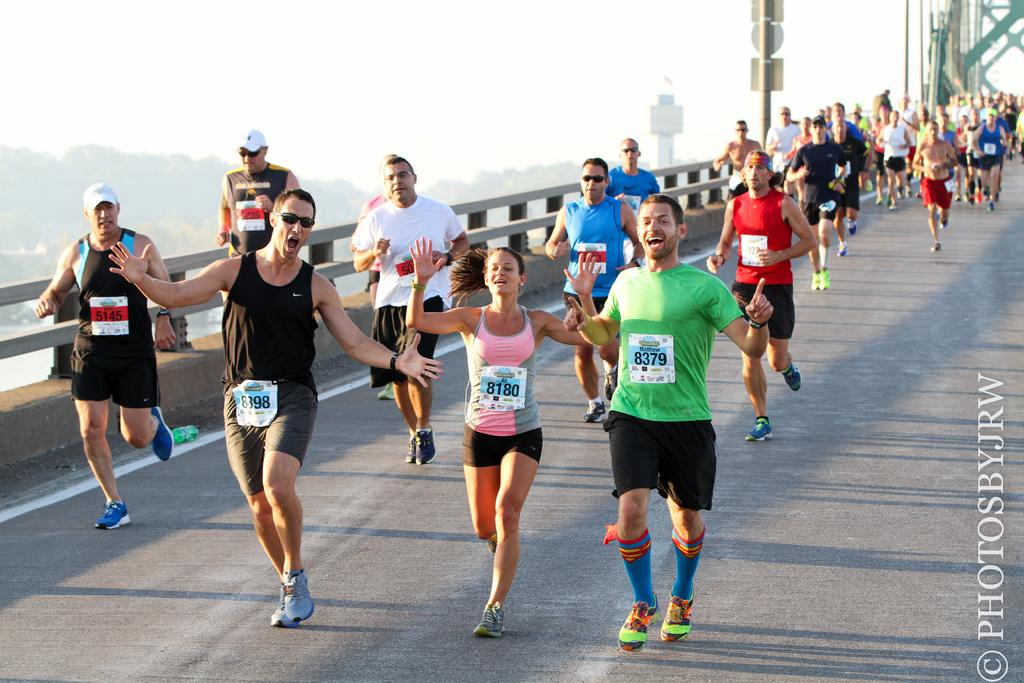What are the people in the image doing? The people in the image are running on the road. What objects can be seen along the road in the image? Boards and poles are visible in the image. What type of barrier is present in the image? There is a fence in the image. What can be seen in the background of the image? Trees and the sky are visible in the background of the image. What type of soap is being used to clean the vacation map in the image? There is no soap, vacation map, or cleaning activity present in the image. 